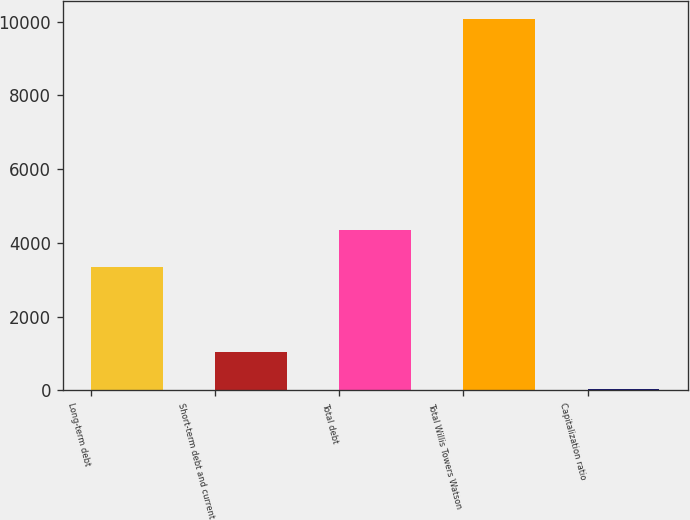Convert chart. <chart><loc_0><loc_0><loc_500><loc_500><bar_chart><fcel>Long-term debt<fcel>Short-term debt and current<fcel>Total debt<fcel>Total Willis Towers Watson<fcel>Capitalization ratio<nl><fcel>3357<fcel>1031.43<fcel>4360.73<fcel>10065<fcel>27.7<nl></chart> 